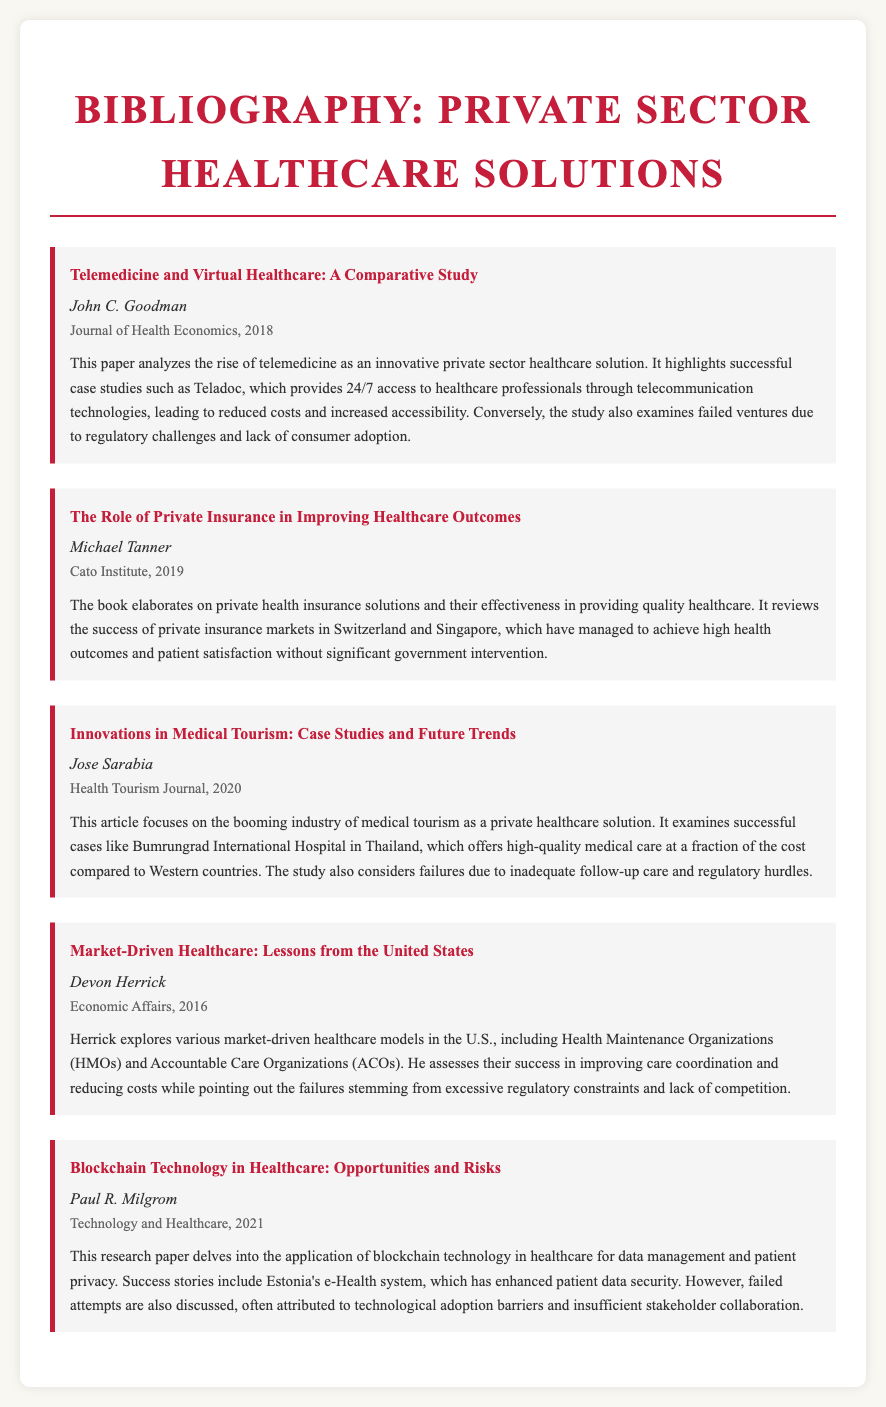What is the title of the first entry? The title of the first entry can be found in the document under the first case study, which is "Telemedicine and Virtual Healthcare: A Comparative Study."
Answer: Telemedicine and Virtual Healthcare: A Comparative Study Who authored the entry on Medical Tourism? The author of the entry titled "Innovations in Medical Tourism: Case Studies and Future Trends" is listed in the document as Jose Sarabia.
Answer: Jose Sarabia In which year was the article on Blockchain Technology published? The publication year for the entry about blockchain is found in the entry details section, which states it was published in 2021.
Answer: 2021 What is the primary focus of Michael Tanner’s book? The primary focus of the book is described in the summary, emphasizing how private health insurance improves healthcare outcomes.
Answer: Improving healthcare outcomes Which successful private sector solution is highlighted in Goodman’s paper? Goodman’s paper mentions "Teladoc" as a successful private sector solution in the field of telemedicine.
Answer: Teladoc What common issue did failures among private healthcare solutions face according to the document? The document indicates that failed ventures often encountered "regulatory challenges" as a common issue.
Answer: Regulatory challenges What type of document is this bibliography presenting? The document type is specified as a "Bibliography" that discusses various private sector healthcare solutions.
Answer: Bibliography In which journal was the entry by Devon Herrick published? The journal in which Herrick's entry appeared is "Economic Affairs," as detailed in the entry.
Answer: Economic Affairs 